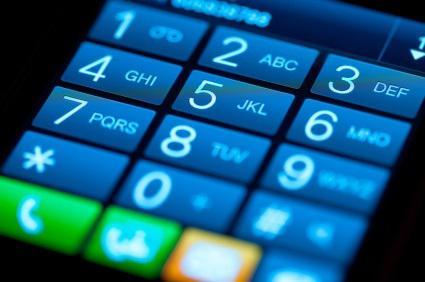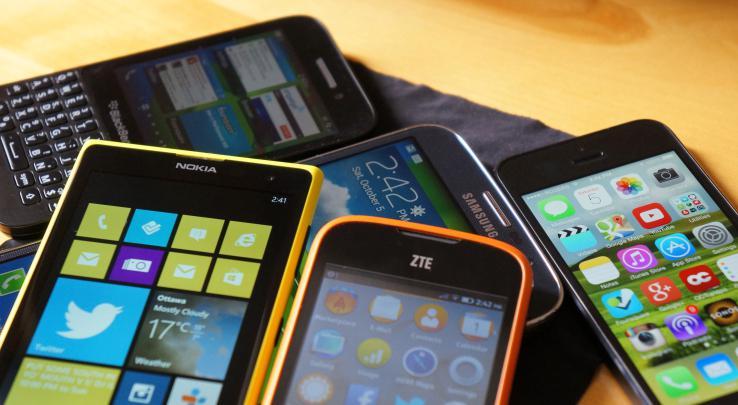The first image is the image on the left, the second image is the image on the right. For the images displayed, is the sentence "A group of phones lies together in the image on the right." factually correct? Answer yes or no. Yes. 